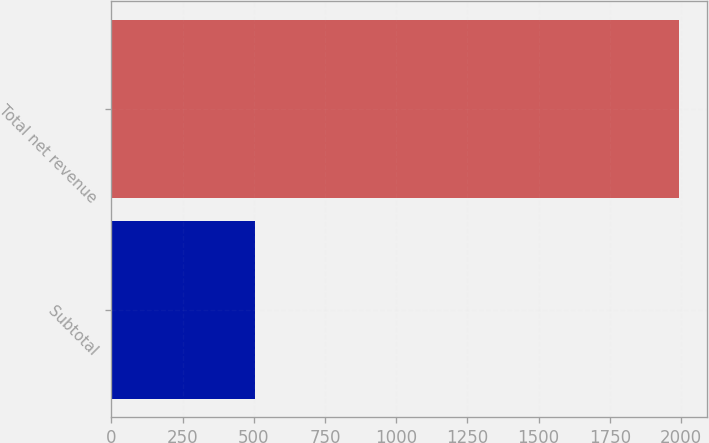Convert chart to OTSL. <chart><loc_0><loc_0><loc_500><loc_500><bar_chart><fcel>Subtotal<fcel>Total net revenue<nl><fcel>503<fcel>1993.1<nl></chart> 